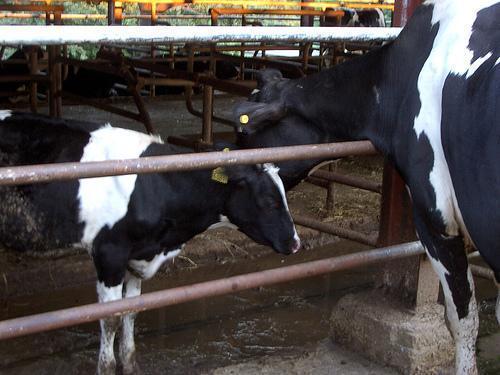How many cows are in the image?
Give a very brief answer. 3. How many yellow ear tags are there?
Give a very brief answer. 2. 